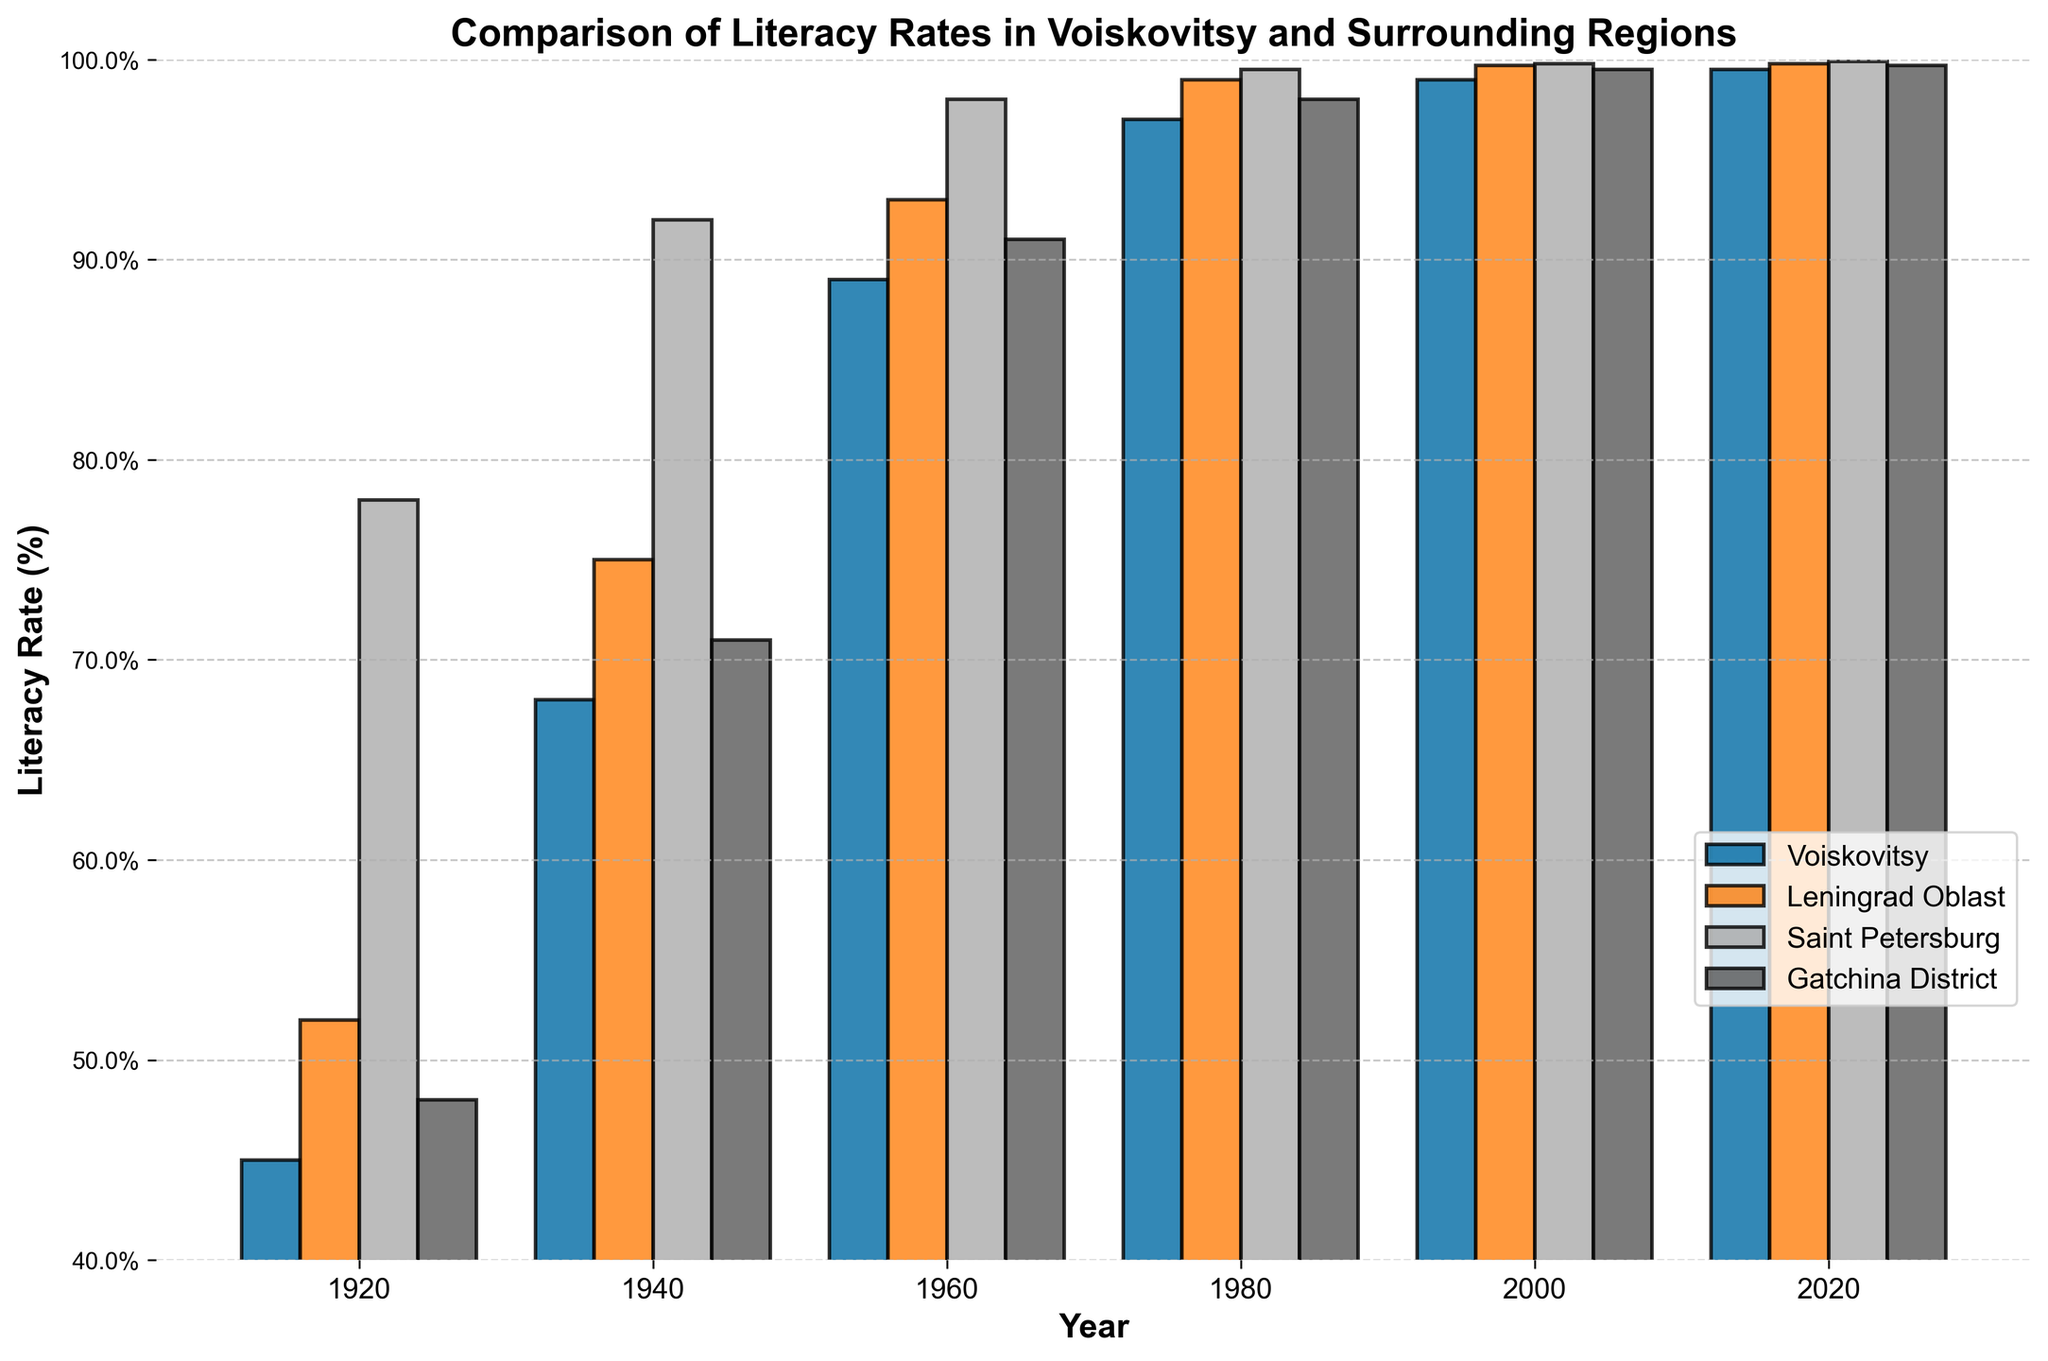What was the literacy rate change in Voiskovitsy between 1920 and 1980? To determine the literacy rate change, subtract the rate in 1920 from the rate in 1980. The values are 97% in 1980 and 45% in 1920, so the change is 97% - 45% = 52%.
Answer: 52% Which region had the highest literacy rate in 1940? Look at the bar heights for all regions in 1940. Saint Petersburg has the tallest bar with a literacy rate of 92%.
Answer: Saint Petersburg What is the average literacy rate of Voiskovitsy over the entire century? Add up the literacy rates of Voiskovitsy for all years and divide by the number of years. (45 + 68 + 89 + 97 + 99 + 99.5) / 6 = 82.25%.
Answer: 82.25% Compare the literacy rates of Saint Petersburg and Gatchina District in 1960. Which one is higher and by how much? Saint Petersburg has a rate of 98% and Gatchina District 91%. Subtract to find the difference, 98% - 91% = 7%.
Answer: Saint Petersburg by 7% In which decade did Voiskovitsy experience the largest increase in literacy rate? Calculate the increase for each interval: 1920-1940 (68-45=23), 1940-1960 (89-68=21), 1960-1980 (97-89=8), 1980-2000 (99-97=2), 2000-2020 (99.5-99=0.5). The largest increase is 23% in 1920-1940.
Answer: 1920-1940 By what percentage did the literacy rate of Voiskovitsy increase from 2000 to 2020? Subtract the rate in 2000 from the rate in 2020. The values are 99.5% in 2020 and 99% in 2000, so the increase is 99.5% - 99% = 0.5%.
Answer: 0.5% Between which two consecutive decades did Gatchina District experience the smallest increase in literacy rate? Calculate the increase for each interval: 1920-1940 (71-48=23), 1940-1960 (91-71=20), 1960-1980 (98-91=7), 1980-2000 (99.5-98=1.5), 2000-2020 (99.7-99.5=0.2). The smallest increase is 0.2 between 2000-2020.
Answer: 2000-2020 Which region had the smallest increase in literacy rate between 1980 and 2020? Calculate the increase for all regions: Voiskovitsy (99.5-97=2.5), Leningrad Oblast (99.8-99=0.8), Saint Petersburg (99.9-99.5=0.4), Gatchina District (99.7-98=1.7). The smallest increase is 0.4% in Saint Petersburg.
Answer: Saint Petersburg 